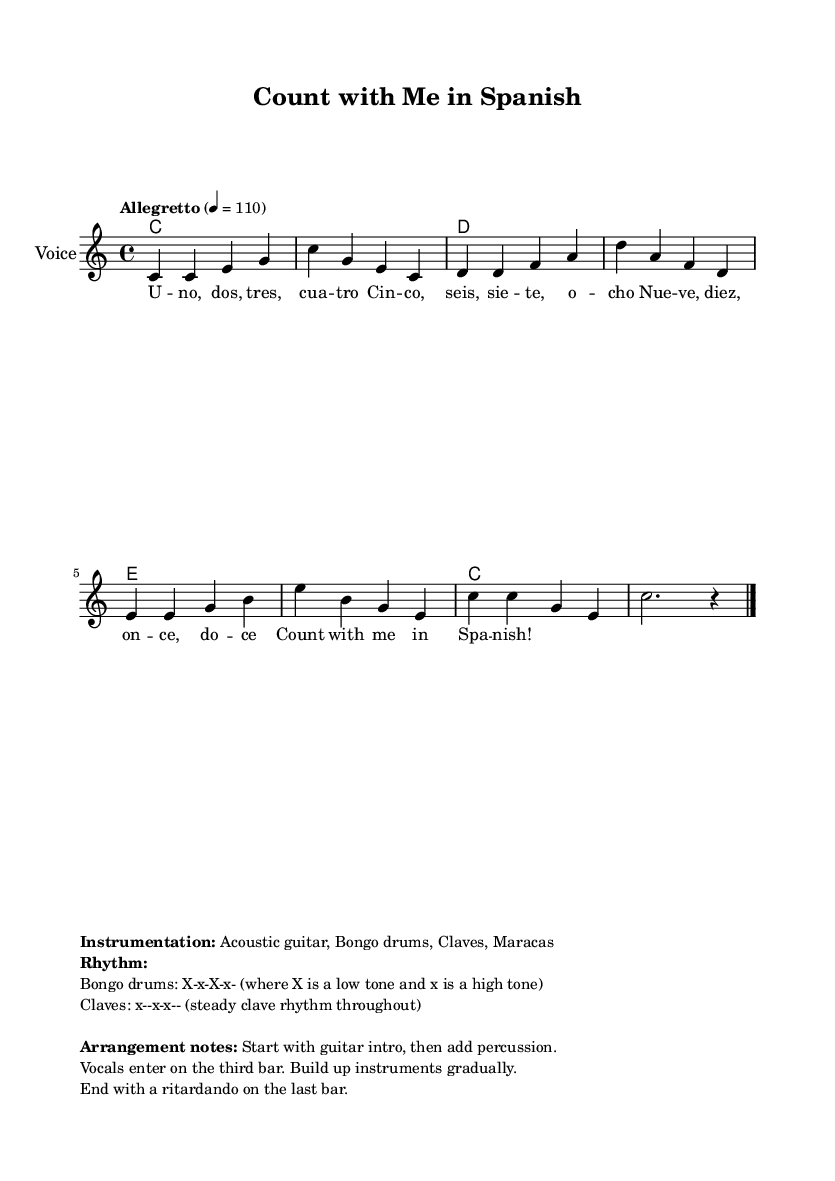What is the key signature of this music? The key signature is indicated as C major, which has no sharps or flats, visible in the initial part of the score.
Answer: C major What is the time signature of the piece? The time signature appears at the start of the score, showing it as 4/4, which means there are four beats in each measure.
Answer: 4/4 What is the tempo marking for this composition? The tempo marking provided in the score is "Allegretto" at a speed of 110 beats per minute, visible in the global settings section.
Answer: Allegretto How many measures does the melody contain? By counting the individual segments of music between the vertical bar lines in the melody section, we see there are eight measures total.
Answer: Eight Which instruments are suggested for the arrangement? The sheet music markup lists "Acoustic guitar, Bongo drums, Claves, Maracas" as the instrumentation.
Answer: Acoustic guitar, Bongo drums, Claves, Maracas What rhythmic pattern is used for the Bongo drums? The rhythm for the Bongo drums is indicated as "X-x-X-x-", where "X" represents a low tone and "x" a high tone, described in the arrangement notes.
Answer: X-x-X-x What word do we finish the lyrics with? The last word of the lyrics, as shown in the words section, is "Spanish," indicating the concluding theme of the song.
Answer: Spanish 